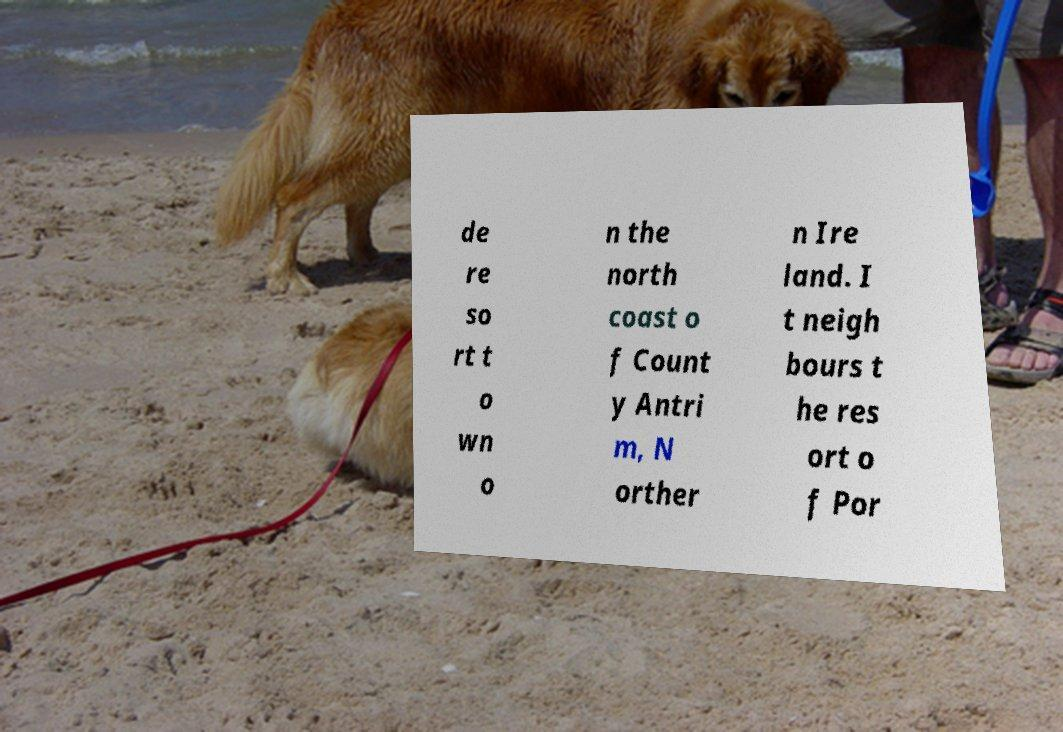What messages or text are displayed in this image? I need them in a readable, typed format. de re so rt t o wn o n the north coast o f Count y Antri m, N orther n Ire land. I t neigh bours t he res ort o f Por 